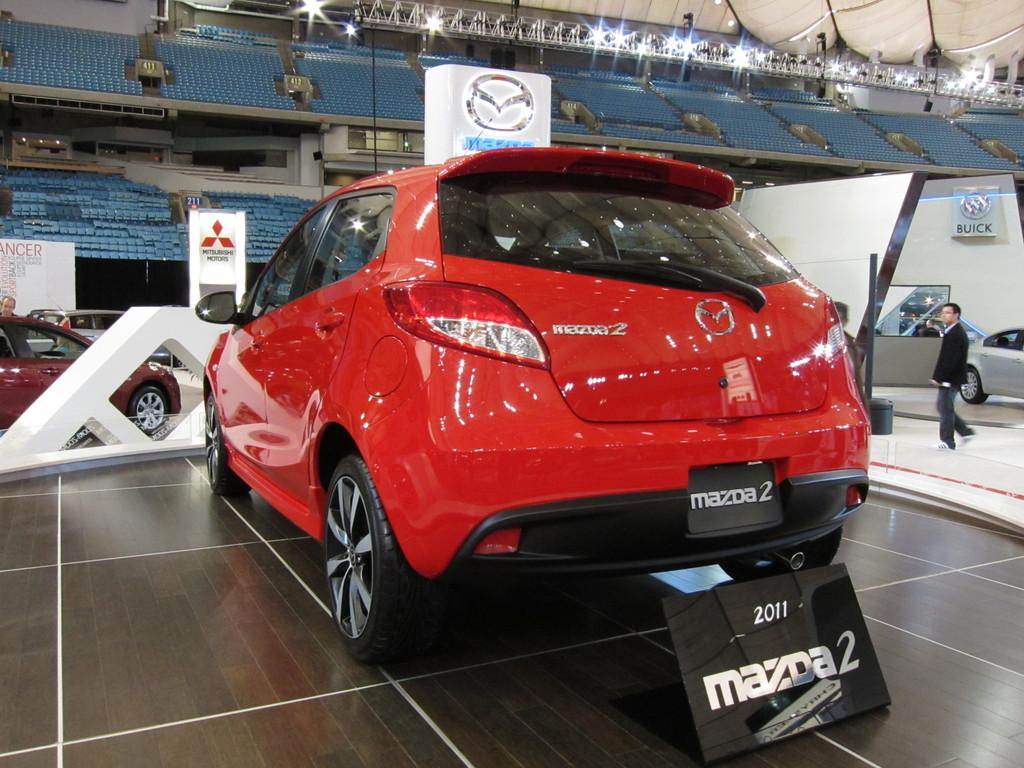What color is the car in the image? The car in the image is red. What is attached to the car in the image? The car has a name board. How many cars can be seen in the image? There are other cars in the image. What else has a name board in the image? There are name boards in the image. What is the person in the image doing? There is a person standing in the image. What type of furniture is present in the image? There are chairs in the image. What is used for hanging lights in the image? There is a lighting truss in the image. What type of illumination is present in the image? There are lights in the image. What type of flowers can be seen growing around the car in the image? There are no flowers visible in the image; it primarily features cars, name boards, a person, chairs, a lighting truss, and lights. 